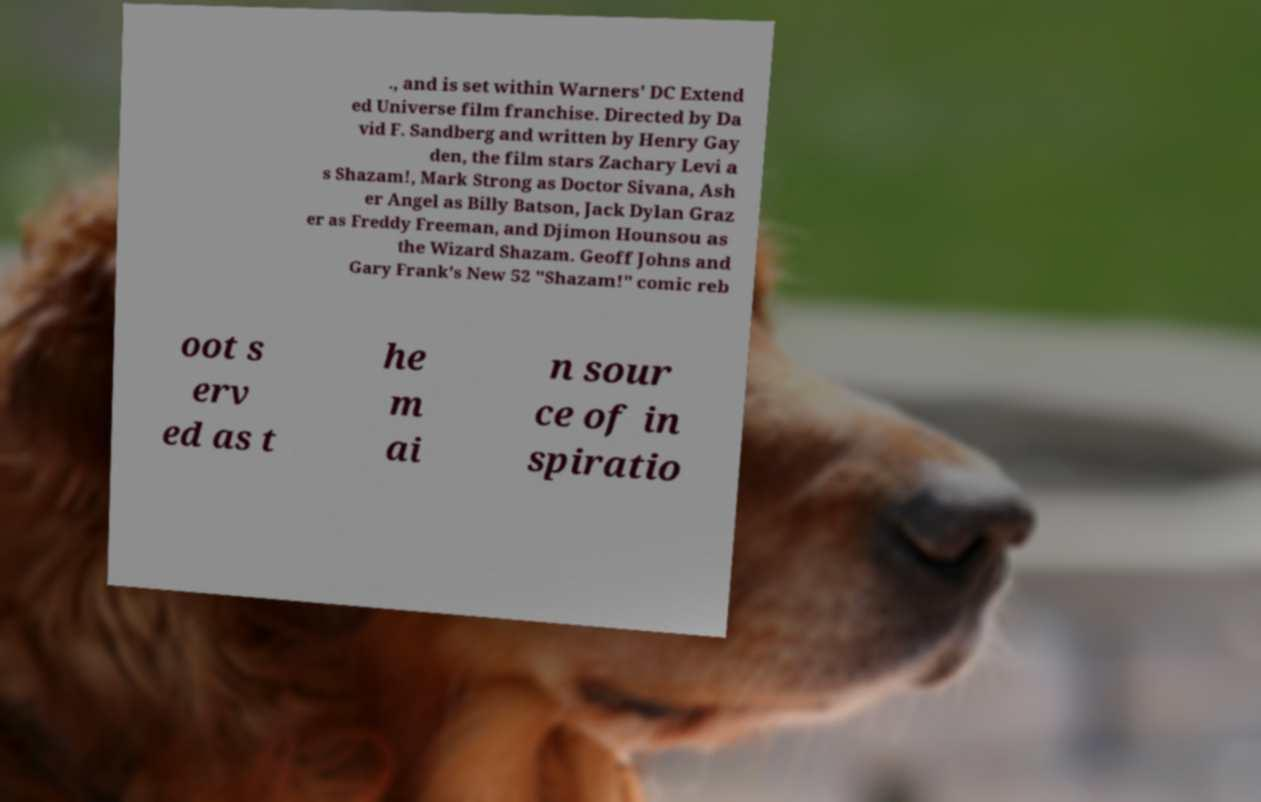Could you extract and type out the text from this image? ., and is set within Warners' DC Extend ed Universe film franchise. Directed by Da vid F. Sandberg and written by Henry Gay den, the film stars Zachary Levi a s Shazam!, Mark Strong as Doctor Sivana, Ash er Angel as Billy Batson, Jack Dylan Graz er as Freddy Freeman, and Djimon Hounsou as the Wizard Shazam. Geoff Johns and Gary Frank's New 52 "Shazam!" comic reb oot s erv ed as t he m ai n sour ce of in spiratio 